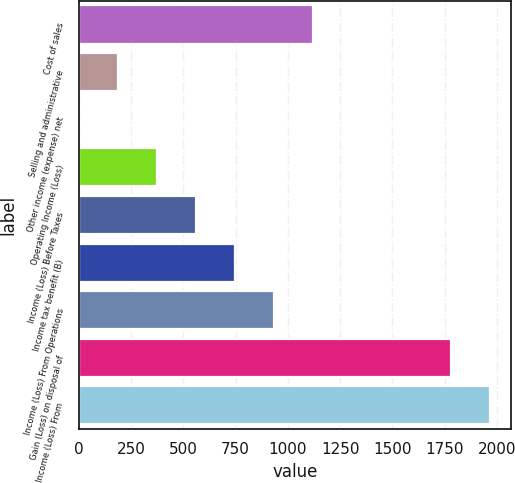Convert chart. <chart><loc_0><loc_0><loc_500><loc_500><bar_chart><fcel>Cost of sales<fcel>Selling and administrative<fcel>Other income (expense) net<fcel>Operating Income (Loss)<fcel>Income (Loss) Before Taxes<fcel>Income tax benefit (B)<fcel>Income (Loss) From Operations<fcel>Gain (Loss) on disposal of<fcel>Income (Loss) From<nl><fcel>1120.28<fcel>188.13<fcel>1.7<fcel>374.56<fcel>560.99<fcel>747.42<fcel>933.85<fcel>1780.5<fcel>1966.93<nl></chart> 